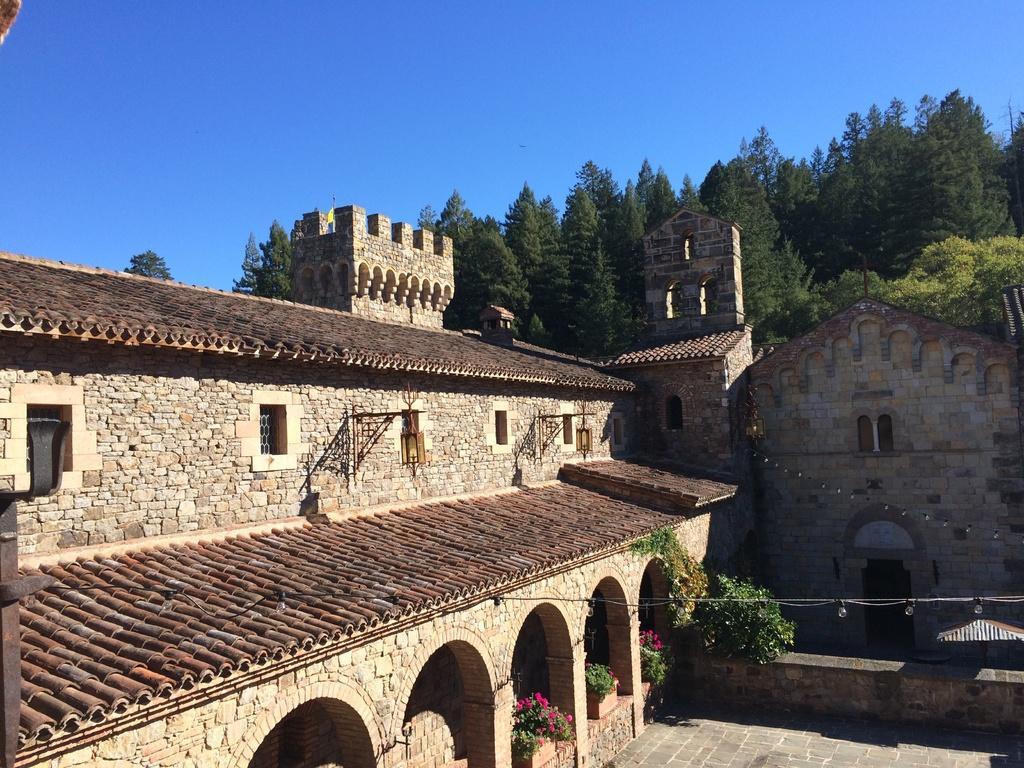Please provide a concise description of this image. On the left side, we see a building which is made up of the stones. Behind that, we see a castle. At the bottom, we see the pavement and the plants which have the pink flowers. On the right side, we see a castle. There are trees in the background. At the top, we see the sky, which is blue in color. 